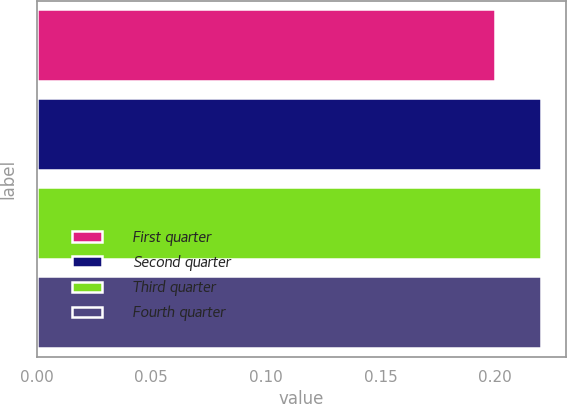Convert chart to OTSL. <chart><loc_0><loc_0><loc_500><loc_500><bar_chart><fcel>First quarter<fcel>Second quarter<fcel>Third quarter<fcel>Fourth quarter<nl><fcel>0.2<fcel>0.22<fcel>0.22<fcel>0.22<nl></chart> 